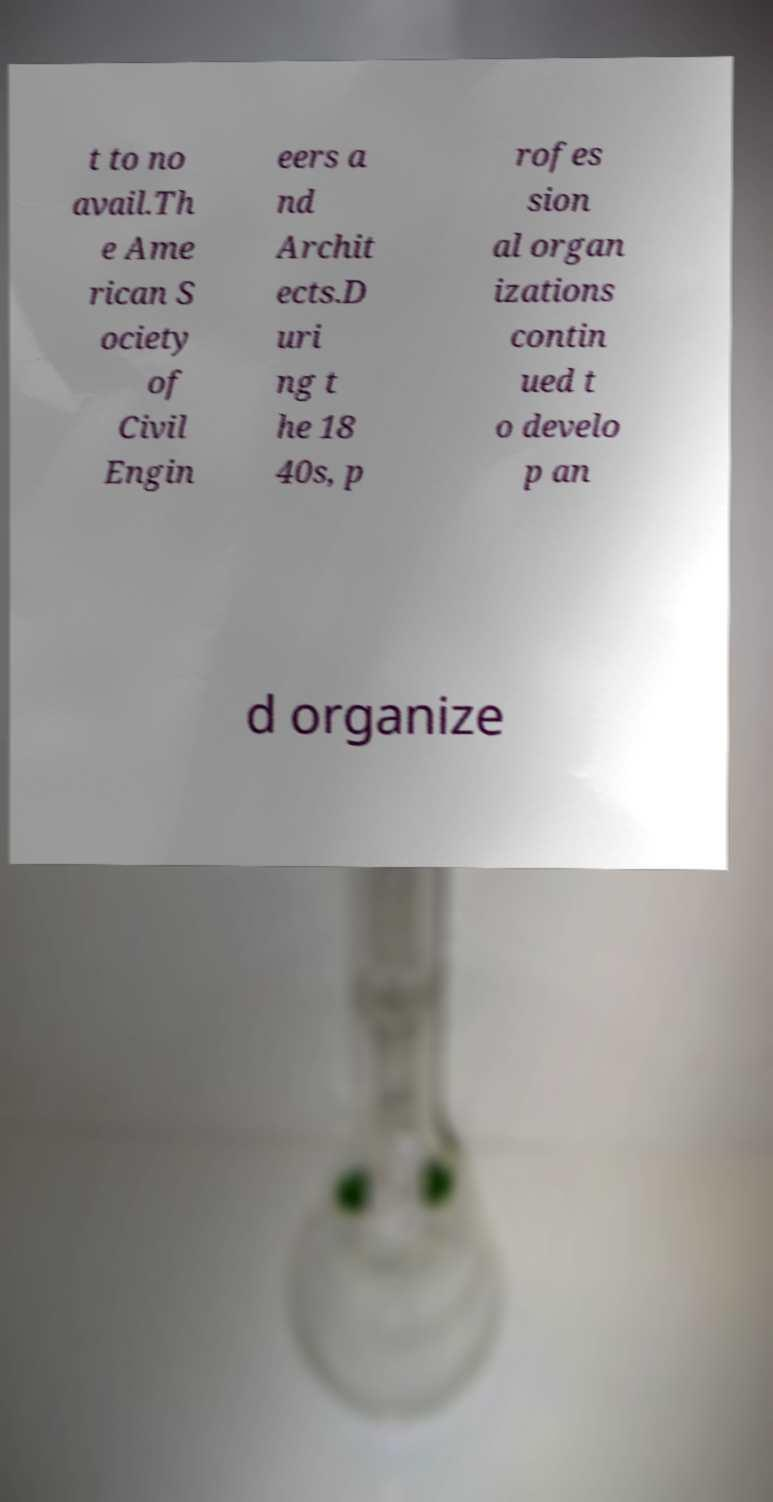Can you read and provide the text displayed in the image?This photo seems to have some interesting text. Can you extract and type it out for me? t to no avail.Th e Ame rican S ociety of Civil Engin eers a nd Archit ects.D uri ng t he 18 40s, p rofes sion al organ izations contin ued t o develo p an d organize 